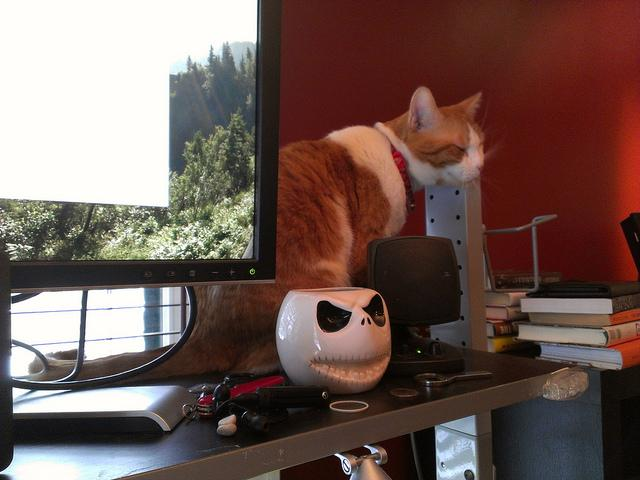What word is appropriate to describe the animal near the books? Please explain your reasoning. mammal. The word is a mammal. 